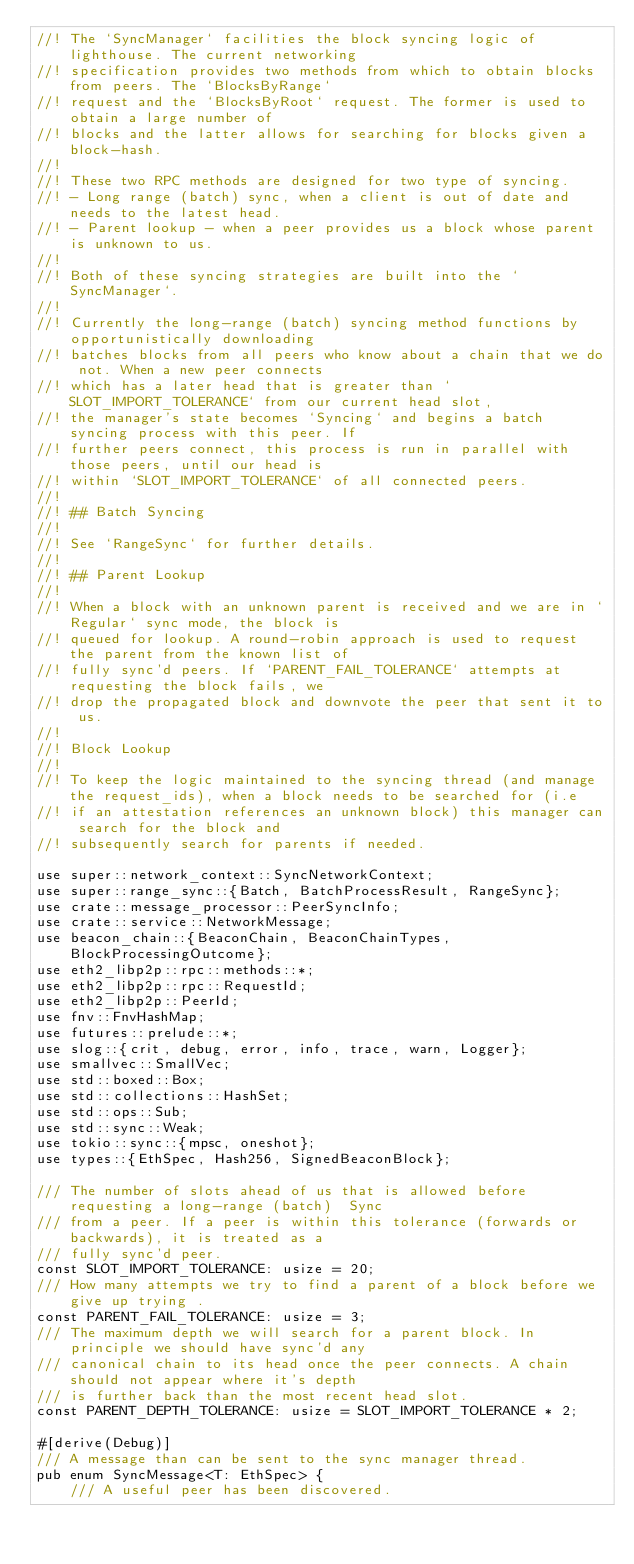Convert code to text. <code><loc_0><loc_0><loc_500><loc_500><_Rust_>//! The `SyncManager` facilities the block syncing logic of lighthouse. The current networking
//! specification provides two methods from which to obtain blocks from peers. The `BlocksByRange`
//! request and the `BlocksByRoot` request. The former is used to obtain a large number of
//! blocks and the latter allows for searching for blocks given a block-hash.
//!
//! These two RPC methods are designed for two type of syncing.
//! - Long range (batch) sync, when a client is out of date and needs to the latest head.
//! - Parent lookup - when a peer provides us a block whose parent is unknown to us.
//!
//! Both of these syncing strategies are built into the `SyncManager`.
//!
//! Currently the long-range (batch) syncing method functions by opportunistically downloading
//! batches blocks from all peers who know about a chain that we do not. When a new peer connects
//! which has a later head that is greater than `SLOT_IMPORT_TOLERANCE` from our current head slot,
//! the manager's state becomes `Syncing` and begins a batch syncing process with this peer. If
//! further peers connect, this process is run in parallel with those peers, until our head is
//! within `SLOT_IMPORT_TOLERANCE` of all connected peers.
//!
//! ## Batch Syncing
//!
//! See `RangeSync` for further details.
//!
//! ## Parent Lookup
//!
//! When a block with an unknown parent is received and we are in `Regular` sync mode, the block is
//! queued for lookup. A round-robin approach is used to request the parent from the known list of
//! fully sync'd peers. If `PARENT_FAIL_TOLERANCE` attempts at requesting the block fails, we
//! drop the propagated block and downvote the peer that sent it to us.
//!
//! Block Lookup
//!
//! To keep the logic maintained to the syncing thread (and manage the request_ids), when a block needs to be searched for (i.e
//! if an attestation references an unknown block) this manager can search for the block and
//! subsequently search for parents if needed.

use super::network_context::SyncNetworkContext;
use super::range_sync::{Batch, BatchProcessResult, RangeSync};
use crate::message_processor::PeerSyncInfo;
use crate::service::NetworkMessage;
use beacon_chain::{BeaconChain, BeaconChainTypes, BlockProcessingOutcome};
use eth2_libp2p::rpc::methods::*;
use eth2_libp2p::rpc::RequestId;
use eth2_libp2p::PeerId;
use fnv::FnvHashMap;
use futures::prelude::*;
use slog::{crit, debug, error, info, trace, warn, Logger};
use smallvec::SmallVec;
use std::boxed::Box;
use std::collections::HashSet;
use std::ops::Sub;
use std::sync::Weak;
use tokio::sync::{mpsc, oneshot};
use types::{EthSpec, Hash256, SignedBeaconBlock};

/// The number of slots ahead of us that is allowed before requesting a long-range (batch)  Sync
/// from a peer. If a peer is within this tolerance (forwards or backwards), it is treated as a
/// fully sync'd peer.
const SLOT_IMPORT_TOLERANCE: usize = 20;
/// How many attempts we try to find a parent of a block before we give up trying .
const PARENT_FAIL_TOLERANCE: usize = 3;
/// The maximum depth we will search for a parent block. In principle we should have sync'd any
/// canonical chain to its head once the peer connects. A chain should not appear where it's depth
/// is further back than the most recent head slot.
const PARENT_DEPTH_TOLERANCE: usize = SLOT_IMPORT_TOLERANCE * 2;

#[derive(Debug)]
/// A message than can be sent to the sync manager thread.
pub enum SyncMessage<T: EthSpec> {
    /// A useful peer has been discovered.</code> 